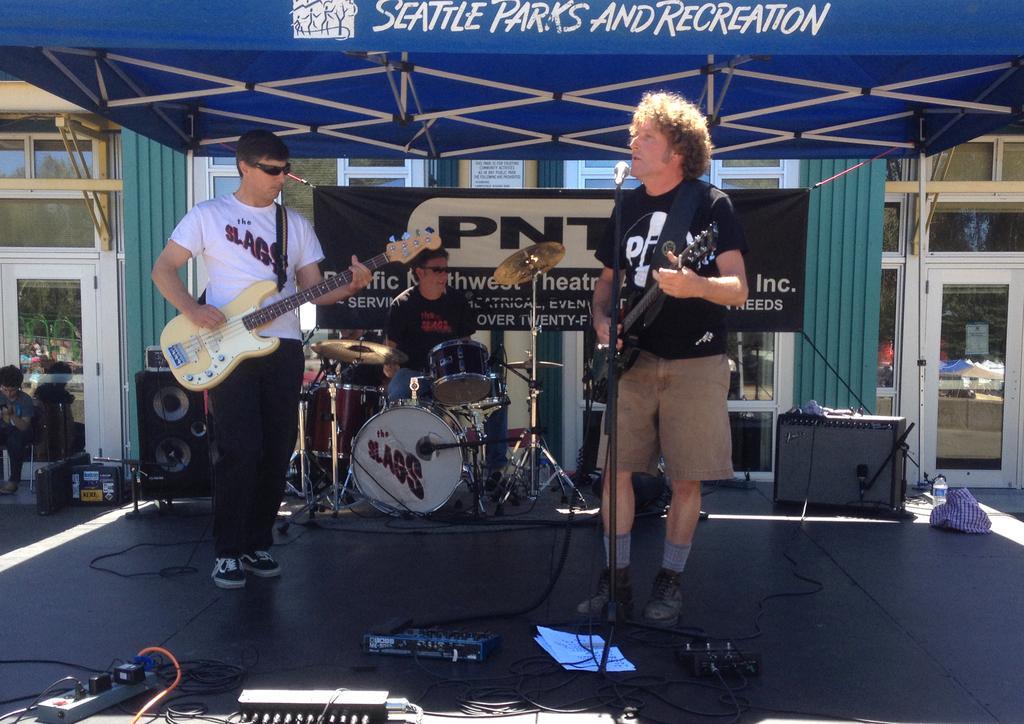Describe this image in one or two sentences. In this image there is a man standing and playing guitar , another person standing and playing guitar, another person sitting and playing drums and the background there is speakers , papers, cables , switch board ,building and a banner. 